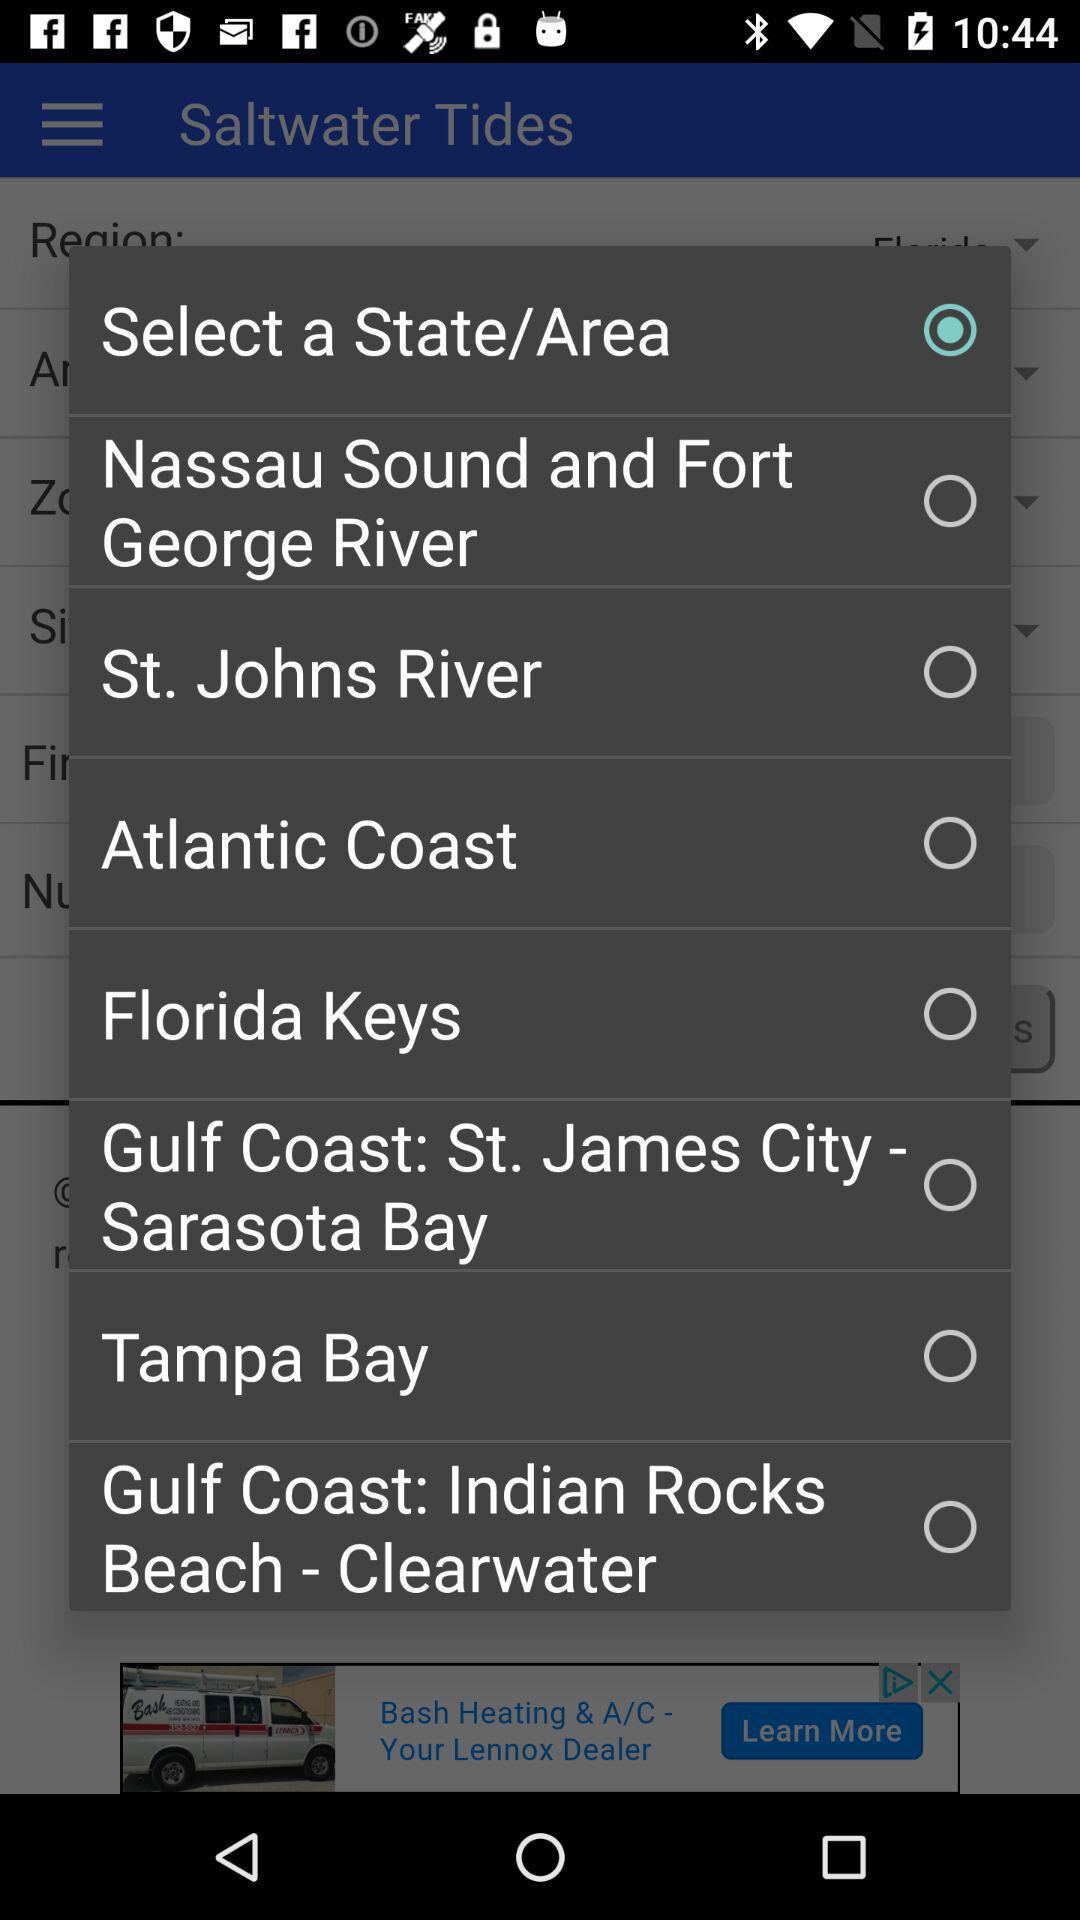What is the status of "Atlantic coast"? The status is "off". 